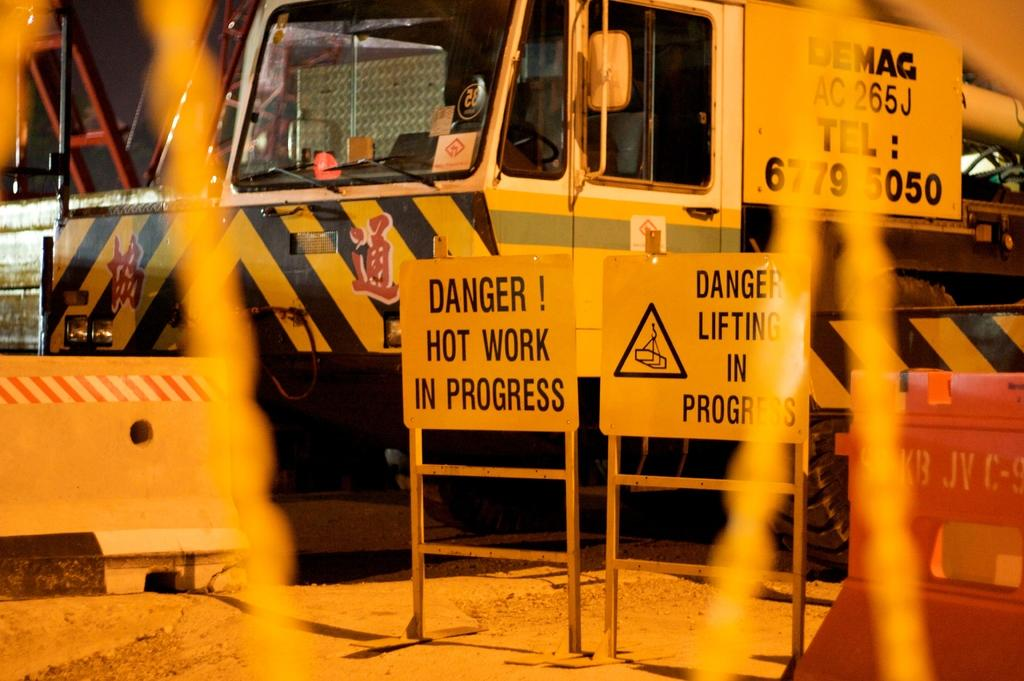Provide a one-sentence caption for the provided image. A danger sign in front of a truck that has an asian language on it. 